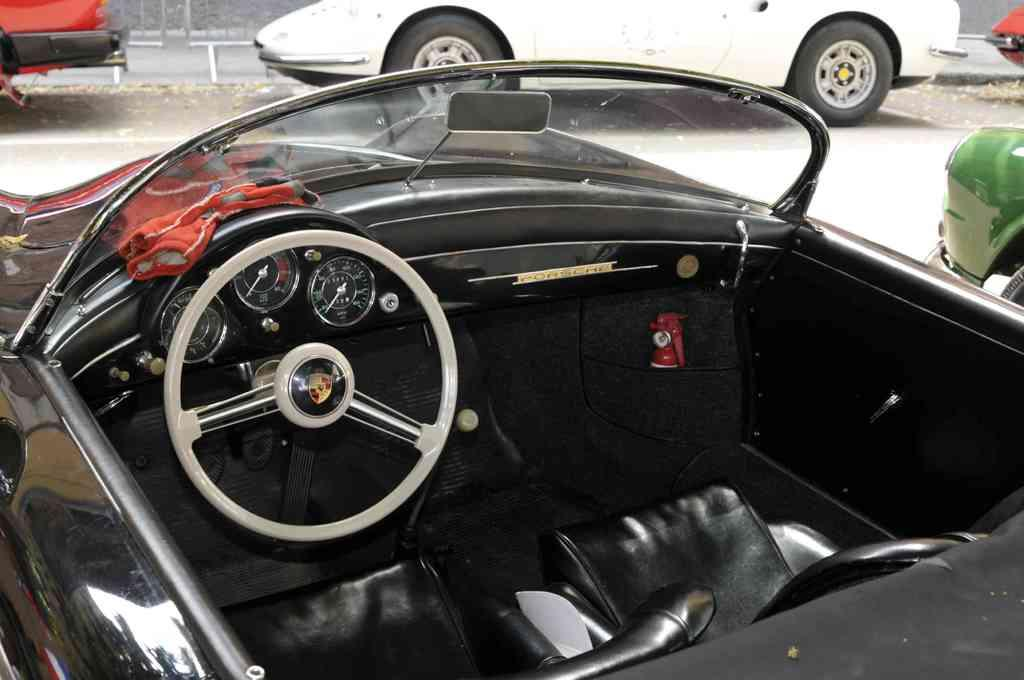What color is the car in the image? The car in the image is black. Can you describe the surrounding environment in the image? There are cars visible in the background of the image. Where is the ladybug performing on the stage in the image? There is no ladybug or stage present in the image; it only features a black car and cars in the background. 